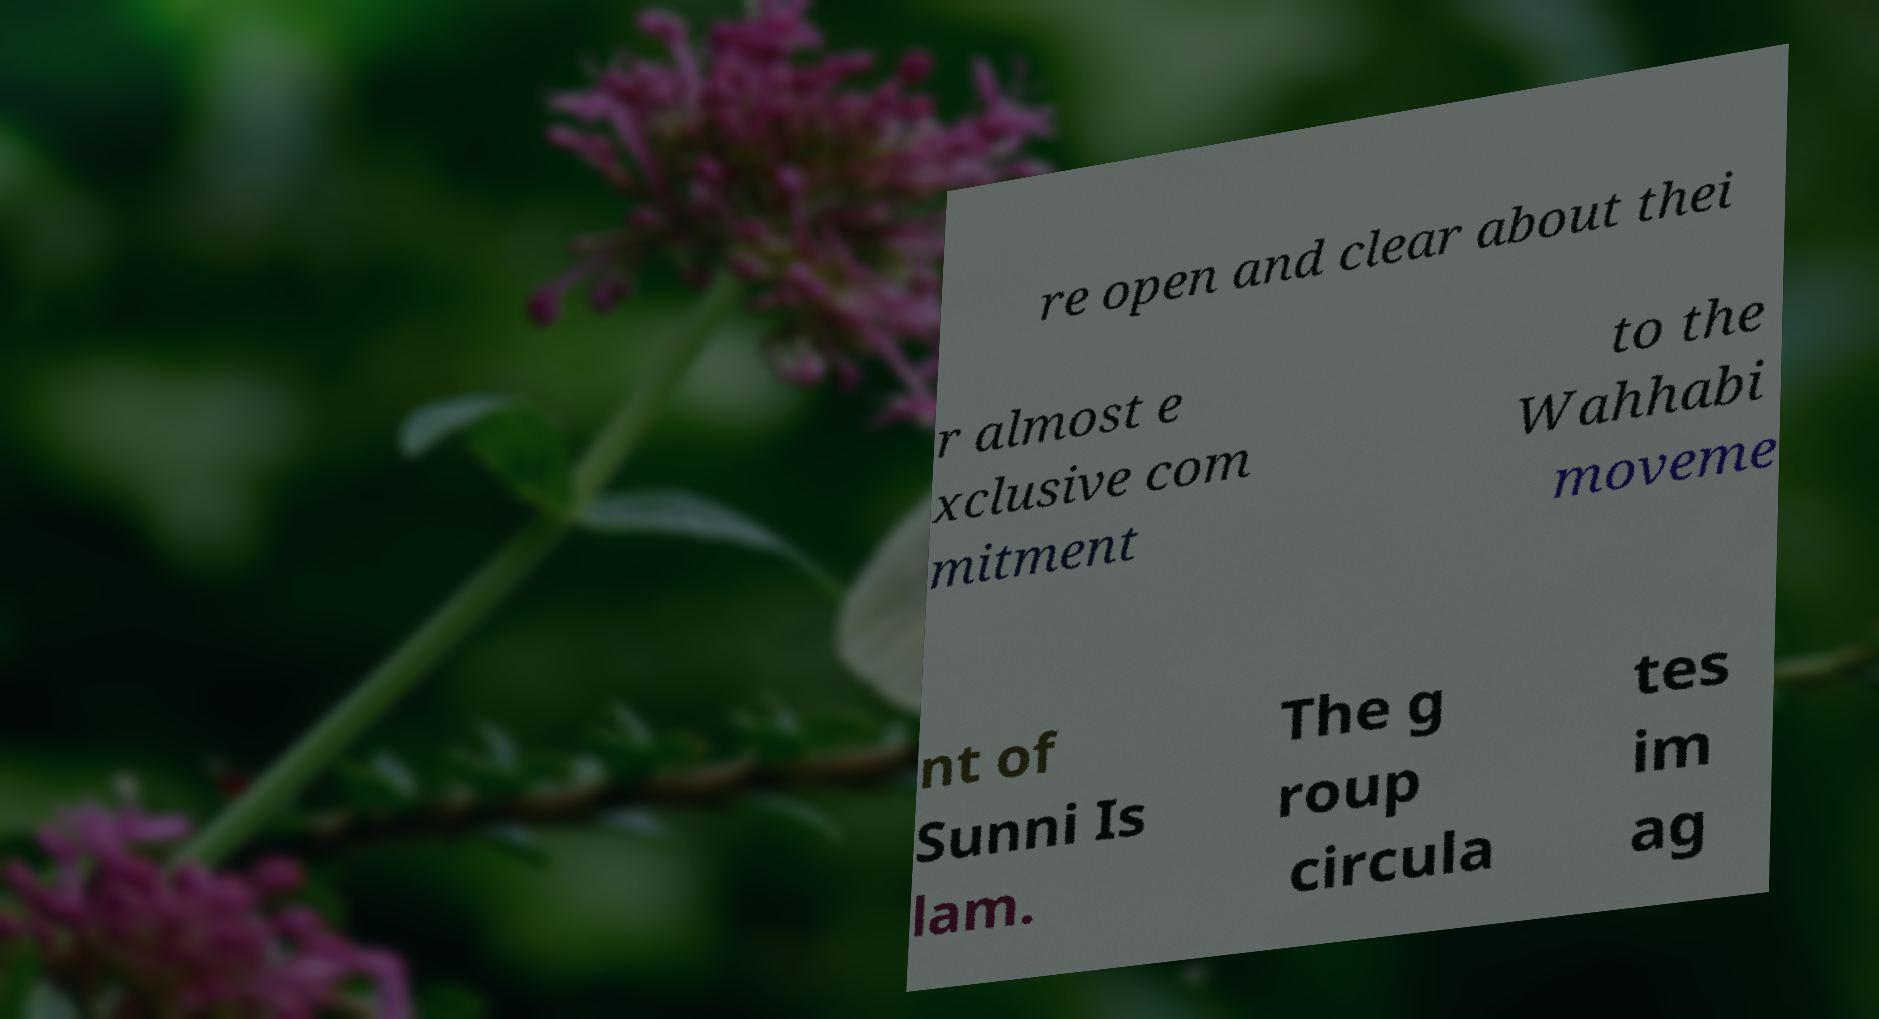I need the written content from this picture converted into text. Can you do that? re open and clear about thei r almost e xclusive com mitment to the Wahhabi moveme nt of Sunni Is lam. The g roup circula tes im ag 